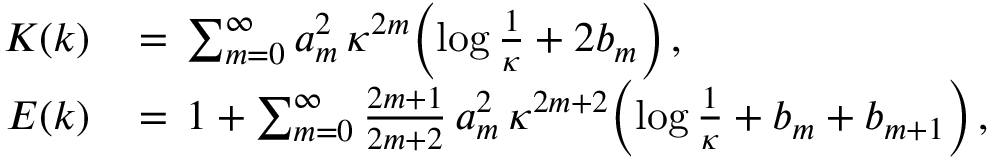<formula> <loc_0><loc_0><loc_500><loc_500>\begin{array} { r l } { K ( k ) \, } & { = \, \sum _ { m = 0 } ^ { \infty } a _ { m } ^ { 2 } \, \kappa ^ { 2 m } \left ( \log \frac { 1 } { \kappa } + 2 b _ { m } \right ) \, , } \\ { E ( k ) \, } & { = \, 1 + \sum _ { m = 0 } ^ { \infty } \frac { 2 m + 1 } { 2 m + 2 } \, a _ { m } ^ { 2 } \, \kappa ^ { 2 m + 2 } \left ( \log \frac { 1 } { \kappa } + b _ { m } + b _ { m + 1 } \right ) \, , } \end{array}</formula> 